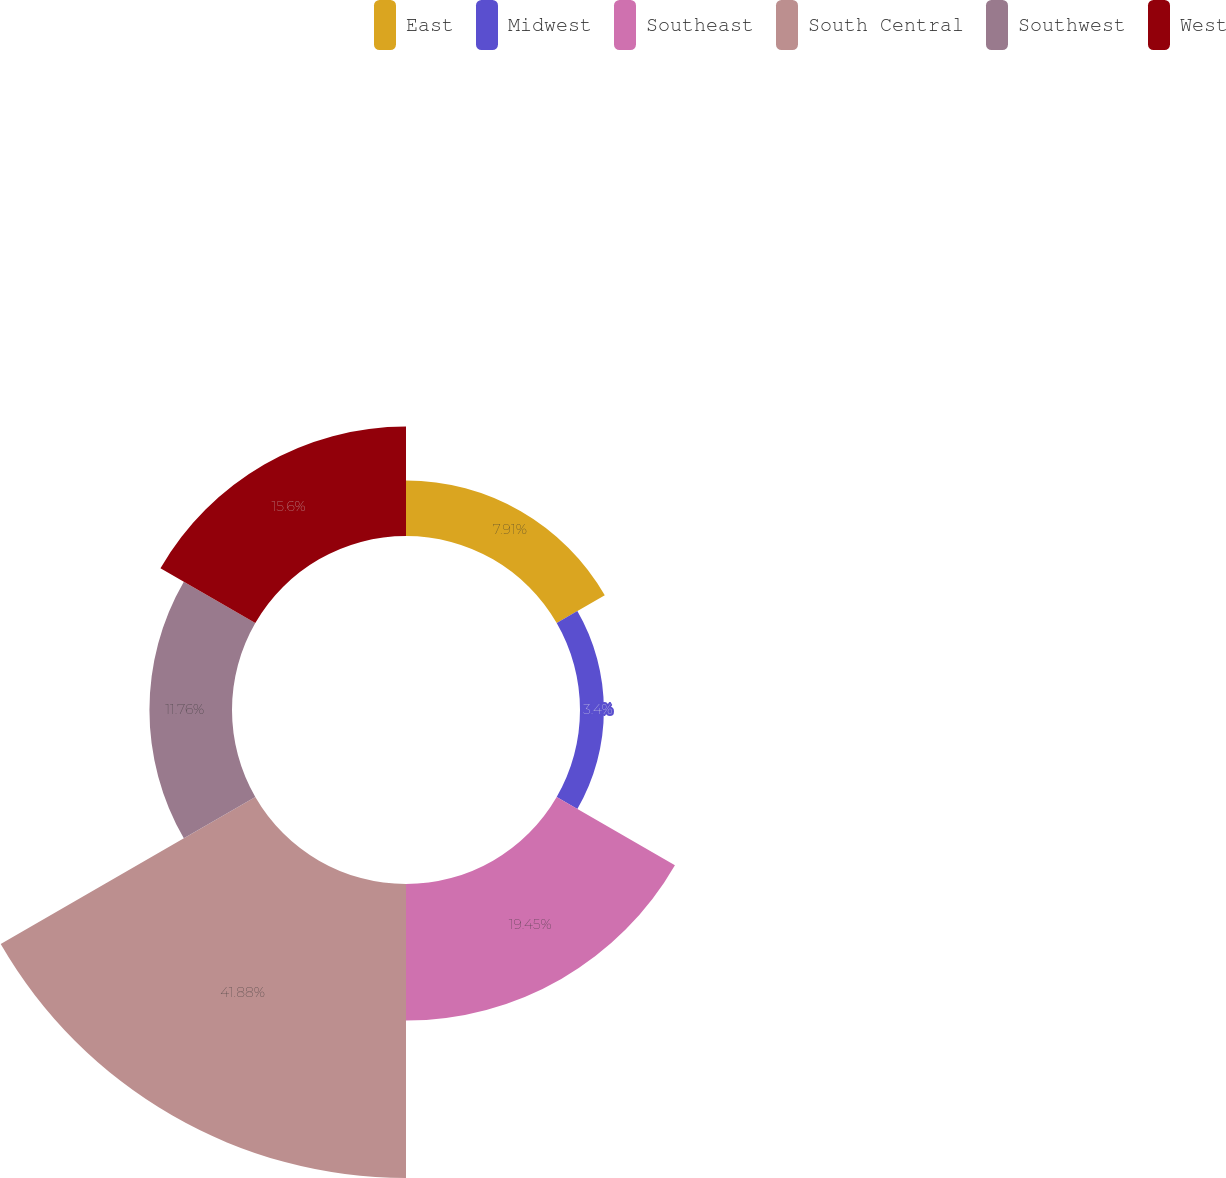Convert chart to OTSL. <chart><loc_0><loc_0><loc_500><loc_500><pie_chart><fcel>East<fcel>Midwest<fcel>Southeast<fcel>South Central<fcel>Southwest<fcel>West<nl><fcel>7.91%<fcel>3.4%<fcel>19.45%<fcel>41.88%<fcel>11.76%<fcel>15.6%<nl></chart> 